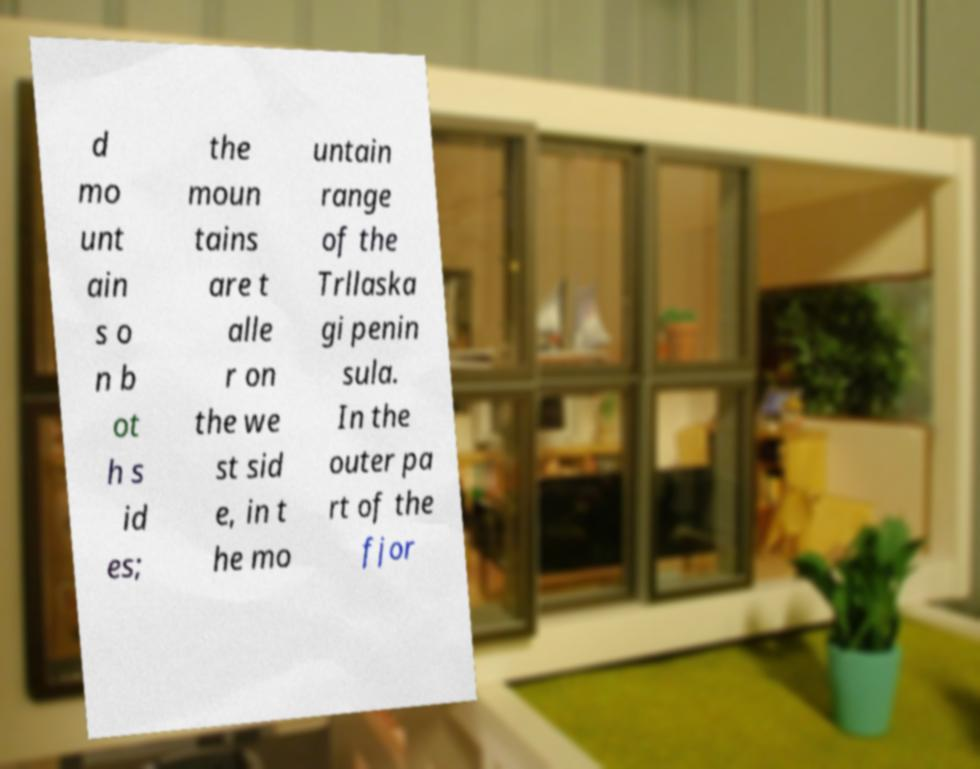I need the written content from this picture converted into text. Can you do that? d mo unt ain s o n b ot h s id es; the moun tains are t alle r on the we st sid e, in t he mo untain range of the Trllaska gi penin sula. In the outer pa rt of the fjor 